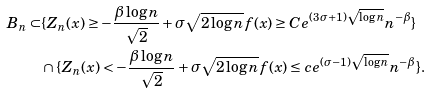Convert formula to latex. <formula><loc_0><loc_0><loc_500><loc_500>B _ { n } \subset & \{ Z _ { n } ( x ) \geq - \frac { \beta \log n } { \sqrt { 2 } } + \sigma \sqrt { 2 \log n } f ( x ) \geq C e ^ { ( 3 \sigma + 1 ) \sqrt { \log n } } n ^ { - \beta } \} \\ & \cap \{ Z _ { n } ( x ) < - \frac { \beta \log n } { \sqrt { 2 } } + \sigma \sqrt { 2 \log n } f ( x ) \leq c e ^ { ( \sigma - 1 ) \sqrt { \log n } } n ^ { - \beta } \} .</formula> 